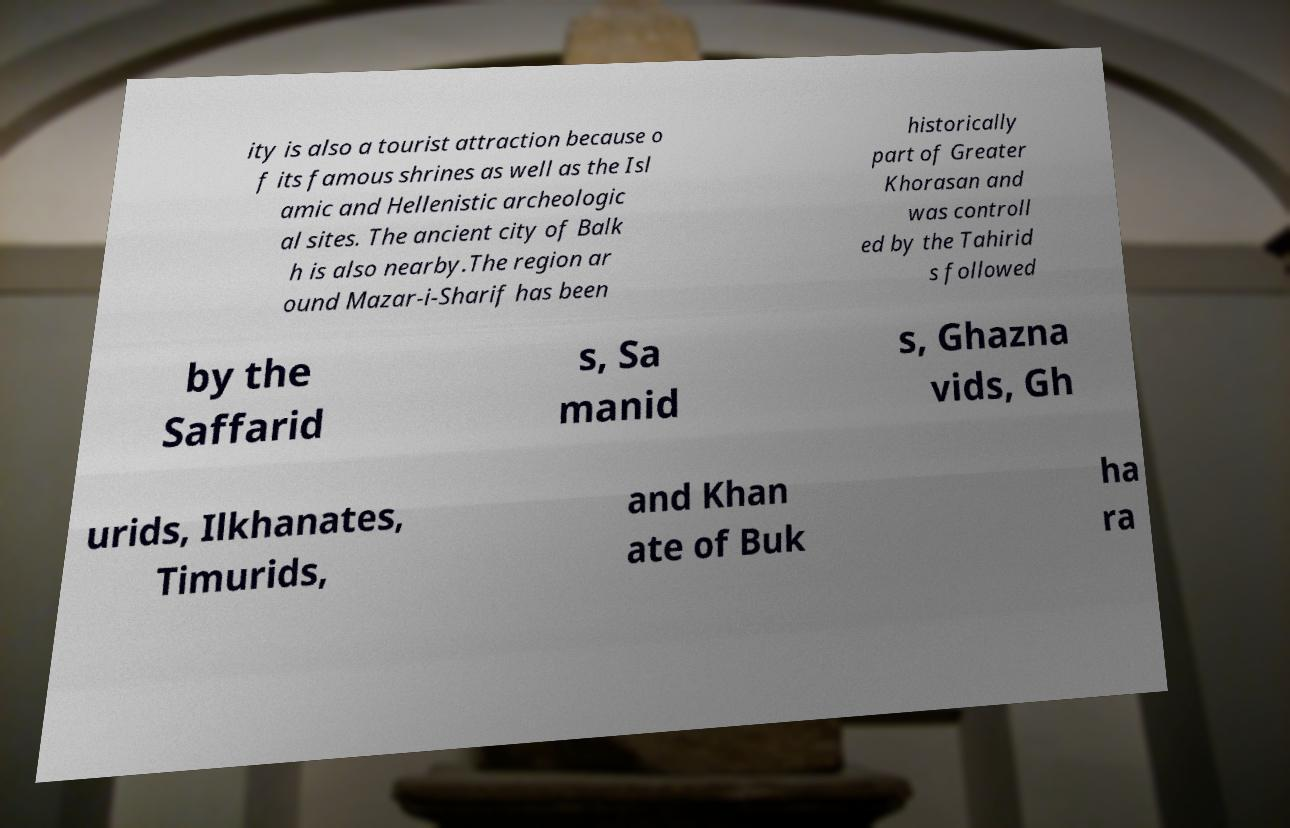What messages or text are displayed in this image? I need them in a readable, typed format. ity is also a tourist attraction because o f its famous shrines as well as the Isl amic and Hellenistic archeologic al sites. The ancient city of Balk h is also nearby.The region ar ound Mazar-i-Sharif has been historically part of Greater Khorasan and was controll ed by the Tahirid s followed by the Saffarid s, Sa manid s, Ghazna vids, Gh urids, Ilkhanates, Timurids, and Khan ate of Buk ha ra 